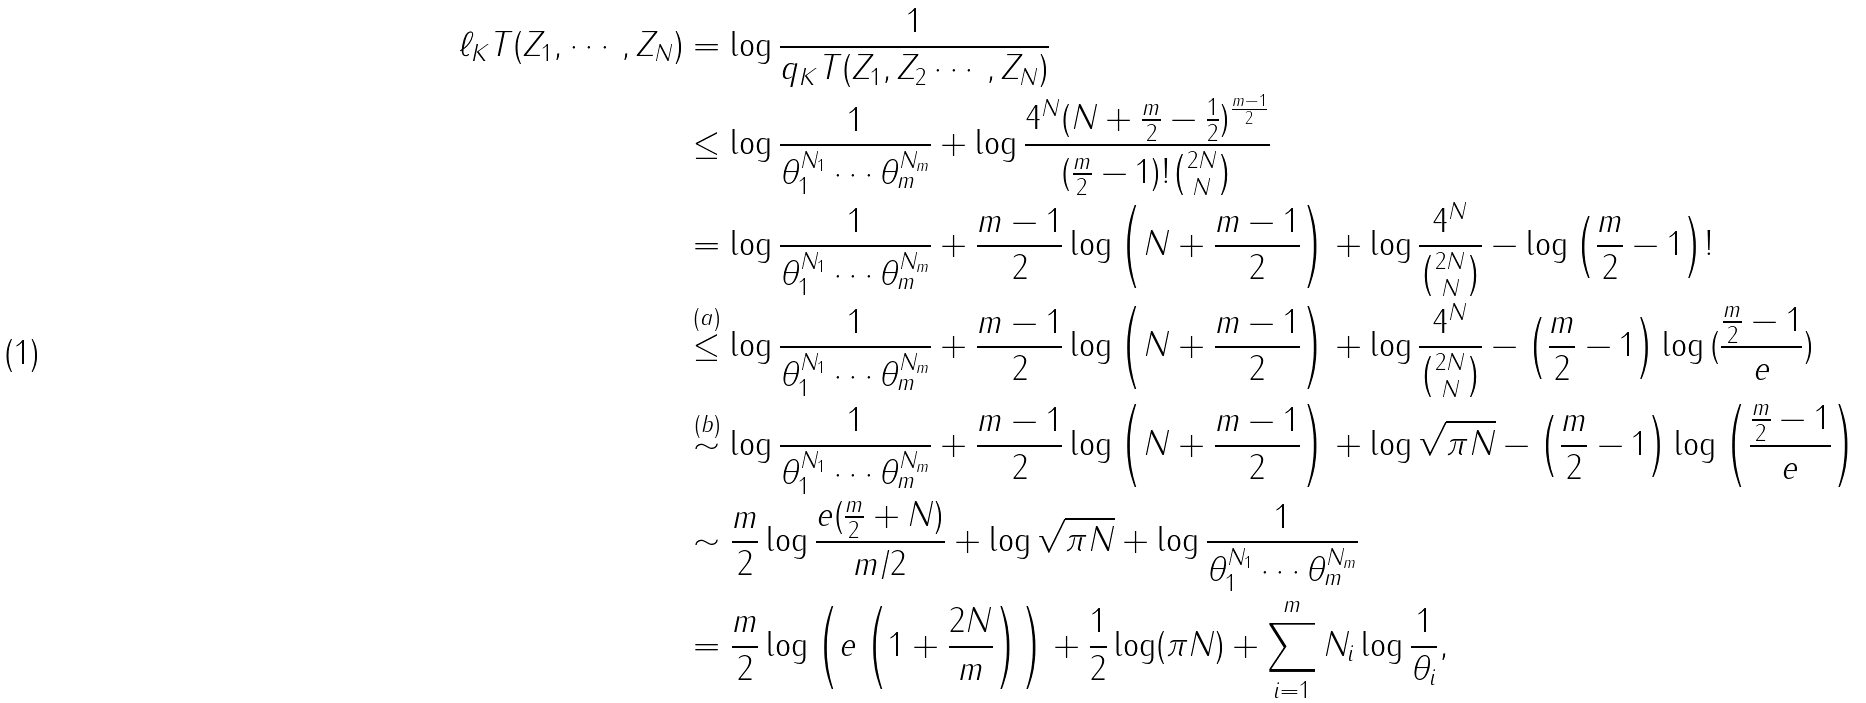<formula> <loc_0><loc_0><loc_500><loc_500>\ell _ { K } T ( Z _ { 1 } , \cdots , Z _ { N } ) & = \log \frac { 1 } { q _ { K } T ( Z _ { 1 } , Z _ { 2 } \cdots , Z _ { N } ) } \\ & \leq \log { \frac { 1 } { \theta _ { 1 } ^ { N _ { 1 } } \cdots \theta _ { m } ^ { N _ { m } } } } + \log { \frac { 4 ^ { N } ( N + \frac { m } { 2 } - \frac { 1 } { 2 } ) ^ { \frac { m - 1 } { 2 } } } { ( \frac { m } { 2 } - 1 ) ! \binom { 2 N } { N } } } \\ & = \log { \frac { 1 } { \theta _ { 1 } ^ { N _ { 1 } } \cdots \theta _ { m } ^ { N _ { m } } } } + \frac { m - 1 } { 2 } \log { \left ( N + \frac { m - 1 } { 2 } \right ) } + \log { \frac { 4 ^ { N } } { \binom { 2 N } { N } } } - \log { \left ( \frac { m } { 2 } - 1 \right ) ! } \\ & \stackrel { ( a ) } { \leq } \log { \frac { 1 } { \theta _ { 1 } ^ { N _ { 1 } } \cdots \theta _ { m } ^ { N _ { m } } } } + \frac { m - 1 } { 2 } \log { \left ( N + \frac { m - 1 } { 2 } \right ) } + \log { \frac { 4 ^ { N } } { \binom { 2 N } { N } } } - \left ( \frac { m } { 2 } - 1 \right ) \log { ( \frac { \frac { m } { 2 } - 1 } { e } ) } \\ & \stackrel { ( b ) } { \sim } \log { \frac { 1 } { \theta _ { 1 } ^ { N _ { 1 } } \cdots \theta _ { m } ^ { N _ { m } } } } + \frac { m - 1 } { 2 } \log { \left ( N + \frac { m - 1 } { 2 } \right ) } + \log { \sqrt { \pi N } } - \left ( \frac { m } { 2 } - 1 \right ) \log { \left ( \frac { \frac { m } { 2 } - 1 } { e } \right ) } \\ & \sim \frac { m } { 2 } \log { \frac { e ( \frac { m } { 2 } + N ) } { m / 2 } } + \log { \sqrt { \pi N } } + \log { \frac { 1 } { \theta _ { 1 } ^ { N _ { 1 } } \cdots \theta _ { m } ^ { N _ { m } } } } \\ & = \frac { m } { 2 } \log \left ( e \left ( 1 + \frac { 2 N } { m } \right ) \right ) + \frac { 1 } { 2 } \log ( \pi N ) + \sum _ { i = 1 } ^ { m } N _ { i } \log { \frac { 1 } { \theta _ { i } } } ,</formula> 